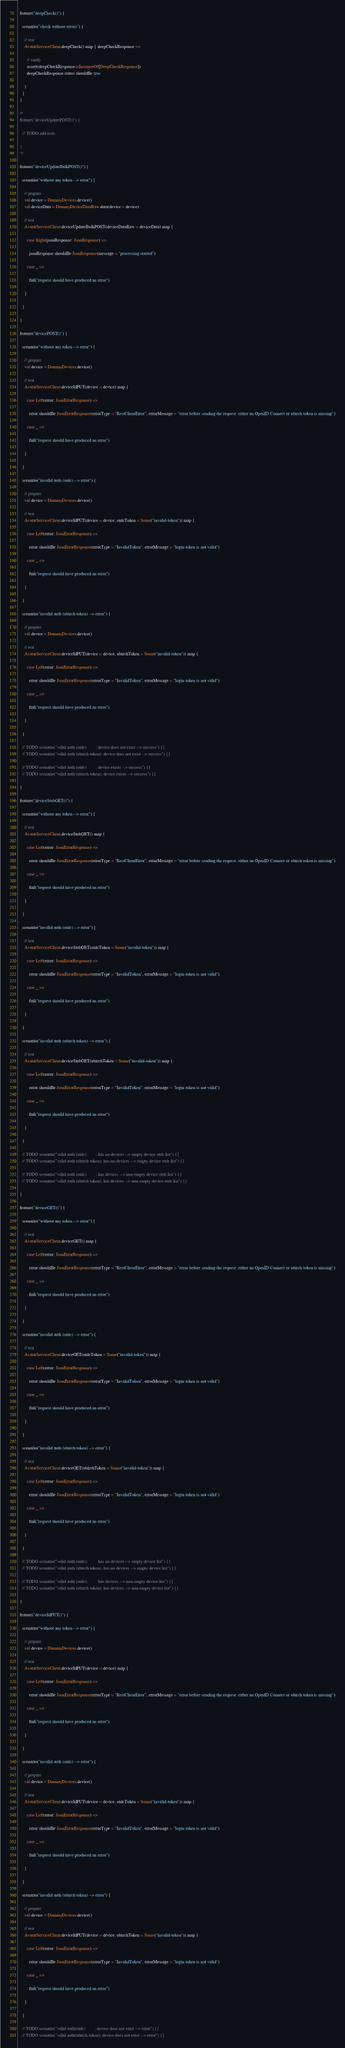<code> <loc_0><loc_0><loc_500><loc_500><_Scala_>
  feature("deepCheck()") {

    scenario("check without errors") {

      // test
      AvatarServiceClient.deepCheck() map { deepCheckResponse =>

        // verify
        assert(deepCheckResponse.isInstanceOf[DeepCheckResponse])
        deepCheckResponse.status shouldBe true

      }
    }
  }

  /*
  feature("deviceUpdatePOST()") {

    // TODO add tests

  }
  */

  feature("deviceUpdateBulkPOST()") {

    scenario("without any token --> error") {

      // prepare
      val device = DummyDevices.device()
      val deviceData = DummyDeviceDataRaw.data(device = device)

      // test
      AvatarServiceClient.deviceUpdateBulkPOST(deviceDataRaw = deviceData) map {

        case Right(jsonResponse: JsonResponse) =>

          jsonResponse shouldBe JsonResponse(message = "processing started")

        case _ =>

          fail("request should have produced an error")

      }

    }

  }

  feature("devicePOST()") {

    scenario("without any token --> error") {

      // prepare
      val device = DummyDevices.device()

      // test
      AvatarServiceClient.deviceIdPUT(device = device) map {

        case Left(error: JsonErrorResponse) =>

          error shouldBe JsonErrorResponse(errorType = "RestClientError", errorMessage = "error before sending the request: either an OpenID Connect or ubirch token is missing")

        case _ =>

          fail("request should have produced an error")

      }

    }

    scenario("invalid auth (oidc) --> error") {

      // prepare
      val device = DummyDevices.device()

      // test
      AvatarServiceClient.deviceIdPUT(device = device, oidcToken = Some("invalid-token")) map {

        case Left(error: JsonErrorResponse) =>

          error shouldBe JsonErrorResponse(errorType = "InvalidToken", errorMessage = "login token is not valid")

        case _ =>

          fail("request should have produced an error")

      }

    }

    scenario("invalid auth (ubirch token) --> error") {

      // prepare
      val device = DummyDevices.device()

      // test
      AvatarServiceClient.deviceIdPUT(device = device, ubirchToken = Some("invalid-token")) map {

        case Left(error: JsonErrorResponse) =>

          error shouldBe JsonErrorResponse(errorType = "InvalidToken", errorMessage = "login token is not valid")

        case _ =>

          fail("request should have produced an error")

      }

    }

    // TODO scenario("valid auth (oidc)        ; device does not exist --> success") {}
    // TODO scenario("valid auth (ubirch token); device does not exist --> success") {}

    // TODO scenario("valid auth (oidc)        ; device exists --> success") {}
    // TODO scenario("valid auth (ubirch token); device exists --> success") {}

  }

  feature("deviceStubGET()") {

    scenario("without any token --> error") {

      // test
      AvatarServiceClient.deviceStubGET() map {

        case Left(error: JsonErrorResponse) =>

          error shouldBe JsonErrorResponse(errorType = "RestClientError", errorMessage = "error before sending the request: either an OpenID Connect or ubirch token is missing")

        case _ =>

          fail("request should have produced an error")

      }

    }

    scenario("invalid auth (oidc) --> error") {

      // test
      AvatarServiceClient.deviceStubGET(oidcToken = Some("invalid-token")) map {

        case Left(error: JsonErrorResponse) =>

          error shouldBe JsonErrorResponse(errorType = "InvalidToken", errorMessage = "login token is not valid")

        case _ =>

          fail("request should have produced an error")

      }

    }

    scenario("invalid auth (ubirch token) --> error") {

      // test
      AvatarServiceClient.deviceStubGET(ubirchToken = Some("invalid-token")) map {

        case Left(error: JsonErrorResponse) =>

          error shouldBe JsonErrorResponse(errorType = "InvalidToken", errorMessage = "login token is not valid")

        case _ =>

          fail("request should have produced an error")

      }

    }

    // TODO scenario("valid auth (oidc)        ; has no devices --> empty device stub list") {}
    // TODO scenario("valid auth (ubirch token); has no devices --> empty device stub list") {}

    // TODO scenario("valid auth (oidc)        ; has devices --> non-empty device stub list") {}
    // TODO scenario("valid auth (ubirch token); has devices --> non-empty device stub list") {}

  }

  feature("deviceGET()") {

    scenario("without any token --> error") {

      // test
      AvatarServiceClient.deviceGET() map {

        case Left(error: JsonErrorResponse) =>

          error shouldBe JsonErrorResponse(errorType = "RestClientError", errorMessage = "error before sending the request: either an OpenID Connect or ubirch token is missing")

        case _ =>

          fail("request should have produced an error")

      }

    }

    scenario("invalid auth (oidc) --> error") {

      // test
      AvatarServiceClient.deviceGET(oidcToken = Some("invalid-token")) map {

        case Left(error: JsonErrorResponse) =>

          error shouldBe JsonErrorResponse(errorType = "InvalidToken", errorMessage = "login token is not valid")

        case _ =>

          fail("request should have produced an error")

      }

    }

    scenario("invalid auth (ubirch token) --> error") {

      // test
      AvatarServiceClient.deviceGET(ubirchToken = Some("invalid-token")) map {

        case Left(error: JsonErrorResponse) =>

          error shouldBe JsonErrorResponse(errorType = "InvalidToken", errorMessage = "login token is not valid")

        case _ =>

          fail("request should have produced an error")

      }

    }

    // TODO scenario("valid auth (oidc);         has no devices --> empty device list") {}
    // TODO scenario("valid auth (ubirch token); has no devices --> empty device list") {}

    // TODO scenario("valid auth (oidc);         has devices --> non-empty device list") {}
    // TODO scenario("valid auth (ubirch token); has devices --> non-empty device list") {}

  }

  feature("deviceIdPUT()") {

    scenario("without any token --> error") {

      // prepare
      val device = DummyDevices.device()

      // test
      AvatarServiceClient.deviceIdPUT(device = device) map {

        case Left(error: JsonErrorResponse) =>

          error shouldBe JsonErrorResponse(errorType = "RestClientError", errorMessage = "error before sending the request: either an OpenID Connect or ubirch token is missing")

        case _ =>

          fail("request should have produced an error")

      }

    }

    scenario("invalid auth (oidc) --> error") {

      // prepare
      val device = DummyDevices.device()

      // test
      AvatarServiceClient.deviceIdPUT(device = device, oidcToken = Some("invalid-token")) map {

        case Left(error: JsonErrorResponse) =>

          error shouldBe JsonErrorResponse(errorType = "InvalidToken", errorMessage = "login token is not valid")

        case _ =>

          fail("request should have produced an error")

      }

    }

    scenario("invalid auth (ubirch token) --> error") {

      // prepare
      val device = DummyDevices.device()

      // test
      AvatarServiceClient.deviceIdPUT(device = device, ubirchToken = Some("invalid-token")) map {

        case Left(error: JsonErrorResponse) =>

          error shouldBe JsonErrorResponse(errorType = "InvalidToken", errorMessage = "login token is not valid")

        case _ =>

          fail("request should have produced an error")

      }

    }

    // TODO scenario("valid auth(oidc)        ; device does not exist --> error") {}
    // TODO scenario("valid auth(ubirch token); device does not exist --> error") {}
</code> 